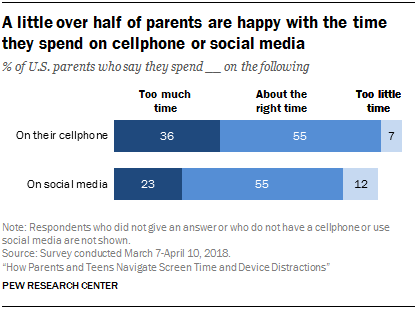Point out several critical features in this image. Yes, satisfactory ratings for time spent on a cellphone and social media are the same. According to a survey, 55% of people are satisfied with their use of their cellphone. 